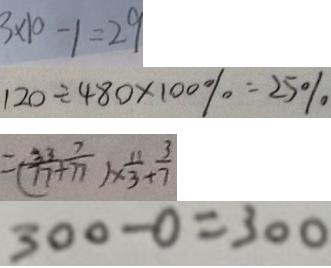Convert formula to latex. <formula><loc_0><loc_0><loc_500><loc_500>3 \times 1 0 - 1 = 2 9 
 1 2 0 \div 4 8 0 \times 1 0 0 \% = 2 5 \% 
 = ( \frac { 3 3 } { 7 7 } + \frac { 7 } { 7 7 } ) \times \frac { 1 1 } { 3 } + \frac { 3 } { 7 } 
 3 0 0 - 0 = 3 0 0</formula> 